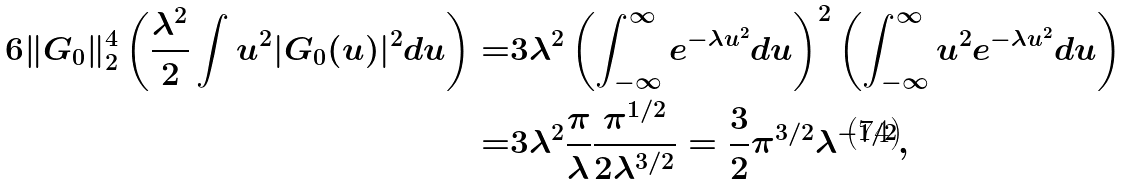Convert formula to latex. <formula><loc_0><loc_0><loc_500><loc_500>6 \| G _ { 0 } \| _ { 2 } ^ { 4 } \left ( \frac { \lambda ^ { 2 } } { 2 } \int u ^ { 2 } | G _ { 0 } ( u ) | ^ { 2 } d u \right ) = & { 3 \lambda ^ { 2 } } \left ( \int _ { - \infty } ^ { \infty } e ^ { - \lambda u ^ { 2 } } d u \right ) ^ { 2 } \left ( \int _ { - \infty } ^ { \infty } u ^ { 2 } e ^ { - \lambda u ^ { 2 } } d u \right ) \\ = & { 3 \lambda ^ { 2 } } \frac { \pi } { \lambda } \frac { \pi ^ { 1 / 2 } } { 2 \lambda ^ { 3 / 2 } } = \frac { 3 } { 2 } \pi ^ { 3 / 2 } \lambda ^ { - 1 / 2 } ,</formula> 